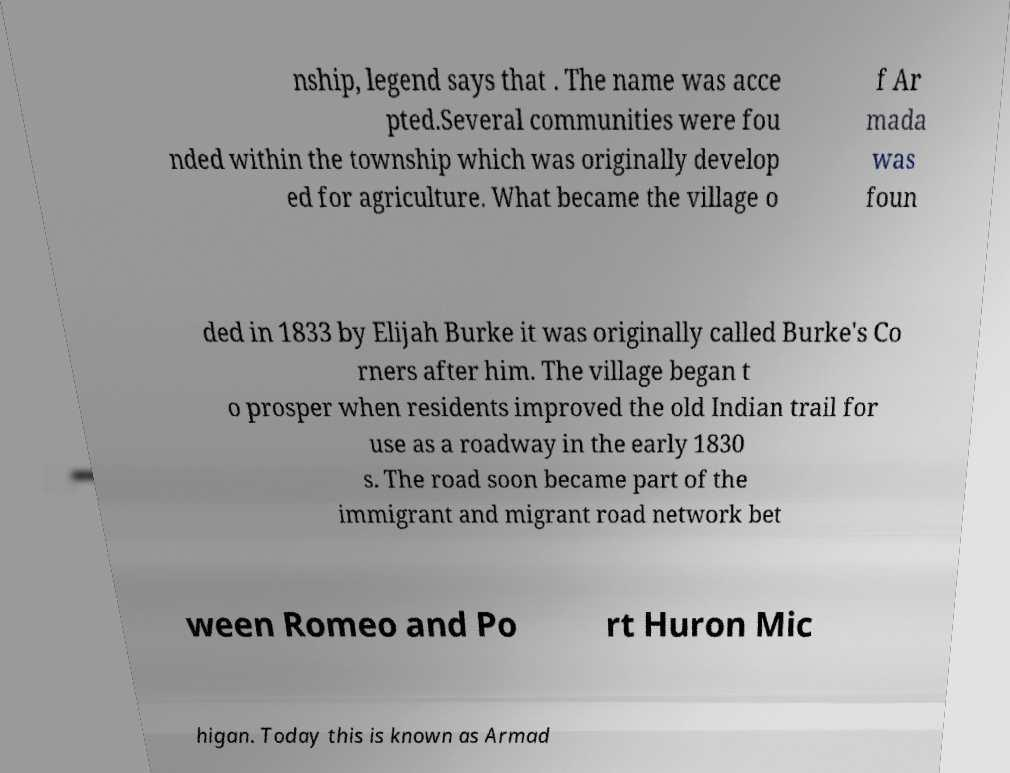For documentation purposes, I need the text within this image transcribed. Could you provide that? nship, legend says that . The name was acce pted.Several communities were fou nded within the township which was originally develop ed for agriculture. What became the village o f Ar mada was foun ded in 1833 by Elijah Burke it was originally called Burke's Co rners after him. The village began t o prosper when residents improved the old Indian trail for use as a roadway in the early 1830 s. The road soon became part of the immigrant and migrant road network bet ween Romeo and Po rt Huron Mic higan. Today this is known as Armad 